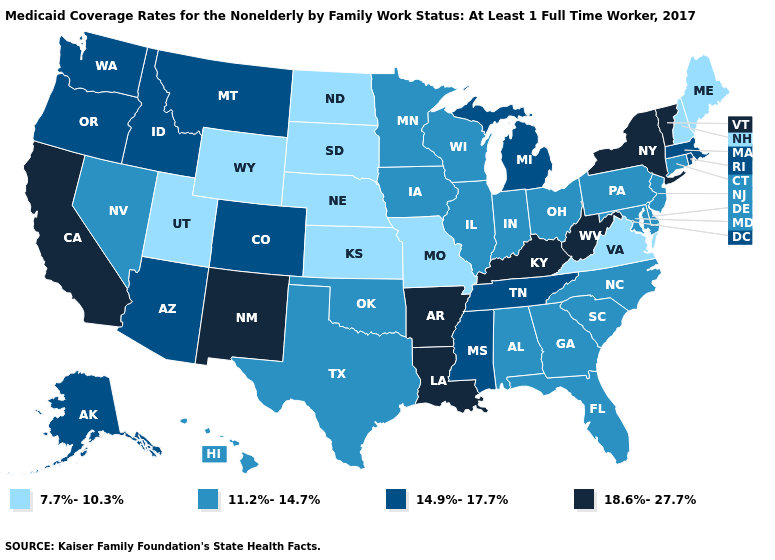What is the value of Louisiana?
Write a very short answer. 18.6%-27.7%. Name the states that have a value in the range 7.7%-10.3%?
Be succinct. Kansas, Maine, Missouri, Nebraska, New Hampshire, North Dakota, South Dakota, Utah, Virginia, Wyoming. Does the map have missing data?
Quick response, please. No. Among the states that border West Virginia , does Kentucky have the highest value?
Write a very short answer. Yes. What is the value of Colorado?
Answer briefly. 14.9%-17.7%. What is the value of Louisiana?
Keep it brief. 18.6%-27.7%. Among the states that border Minnesota , does South Dakota have the highest value?
Short answer required. No. What is the lowest value in states that border New Jersey?
Quick response, please. 11.2%-14.7%. What is the value of Illinois?
Give a very brief answer. 11.2%-14.7%. Name the states that have a value in the range 11.2%-14.7%?
Be succinct. Alabama, Connecticut, Delaware, Florida, Georgia, Hawaii, Illinois, Indiana, Iowa, Maryland, Minnesota, Nevada, New Jersey, North Carolina, Ohio, Oklahoma, Pennsylvania, South Carolina, Texas, Wisconsin. What is the value of Oklahoma?
Keep it brief. 11.2%-14.7%. What is the highest value in states that border Nebraska?
Write a very short answer. 14.9%-17.7%. What is the highest value in the MidWest ?
Short answer required. 14.9%-17.7%. 